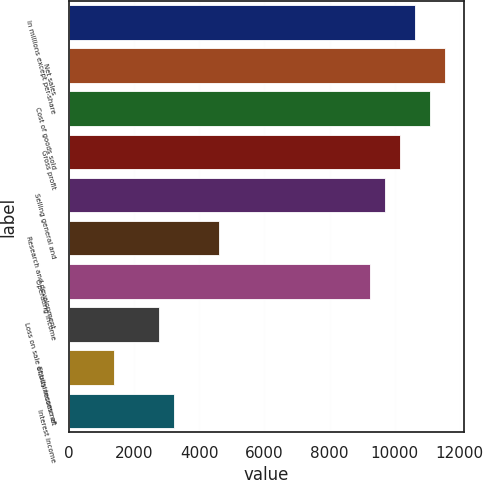Convert chart. <chart><loc_0><loc_0><loc_500><loc_500><bar_chart><fcel>In millions except per-share<fcel>Net sales<fcel>Cost of goods sold<fcel>Gross profit<fcel>Selling general and<fcel>Research and development<fcel>Operating income<fcel>Loss on sale of businesses net<fcel>Equity income of<fcel>Interest income<nl><fcel>10617.5<fcel>11540.7<fcel>11079.1<fcel>10155.8<fcel>9694.22<fcel>4616.4<fcel>9232.6<fcel>2769.92<fcel>1385.06<fcel>3231.54<nl></chart> 